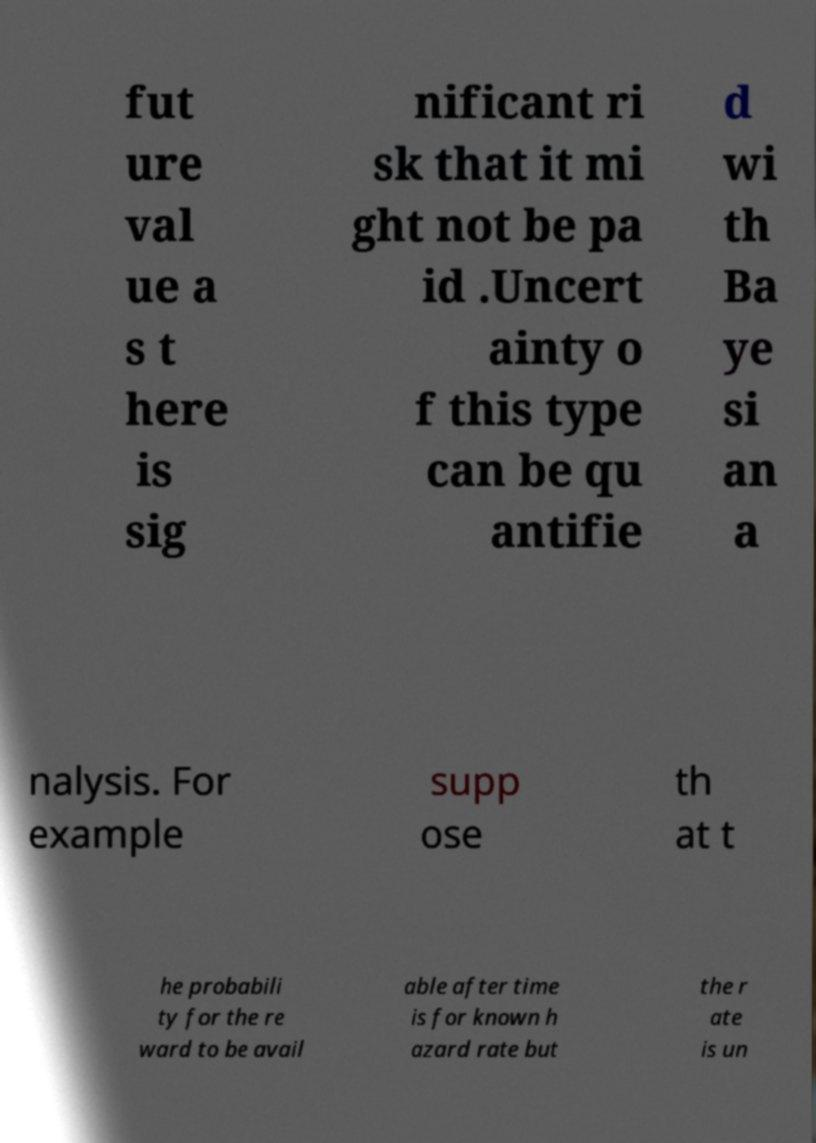There's text embedded in this image that I need extracted. Can you transcribe it verbatim? fut ure val ue a s t here is sig nificant ri sk that it mi ght not be pa id .Uncert ainty o f this type can be qu antifie d wi th Ba ye si an a nalysis. For example supp ose th at t he probabili ty for the re ward to be avail able after time is for known h azard rate but the r ate is un 